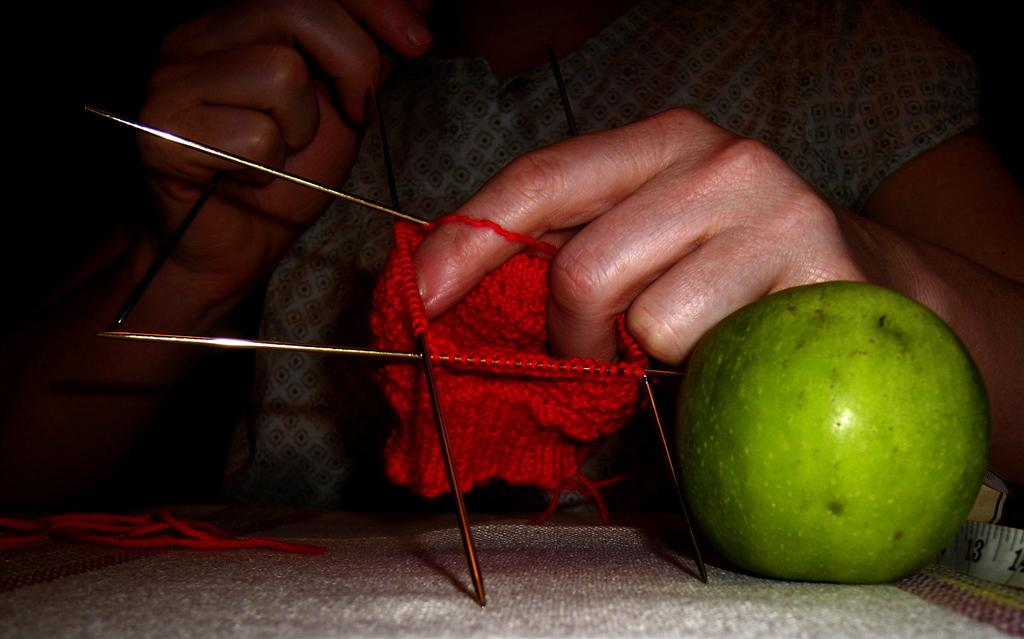What activity is the person in the image engaged in? The person in the image is doing thread works with needles. What type of fruit can be seen in the image? There is a green color fruit in the image. What object related to adhesion or attachment is present in the image? There is a tape in the image. How many hands does the person's brother have in the image? There is no mention of a brother or hands in the image, so it cannot be determined. 